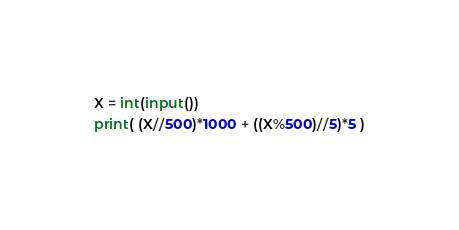<code> <loc_0><loc_0><loc_500><loc_500><_Python_>X = int(input())
print( (X//500)*1000 + ((X%500)//5)*5 )
</code> 